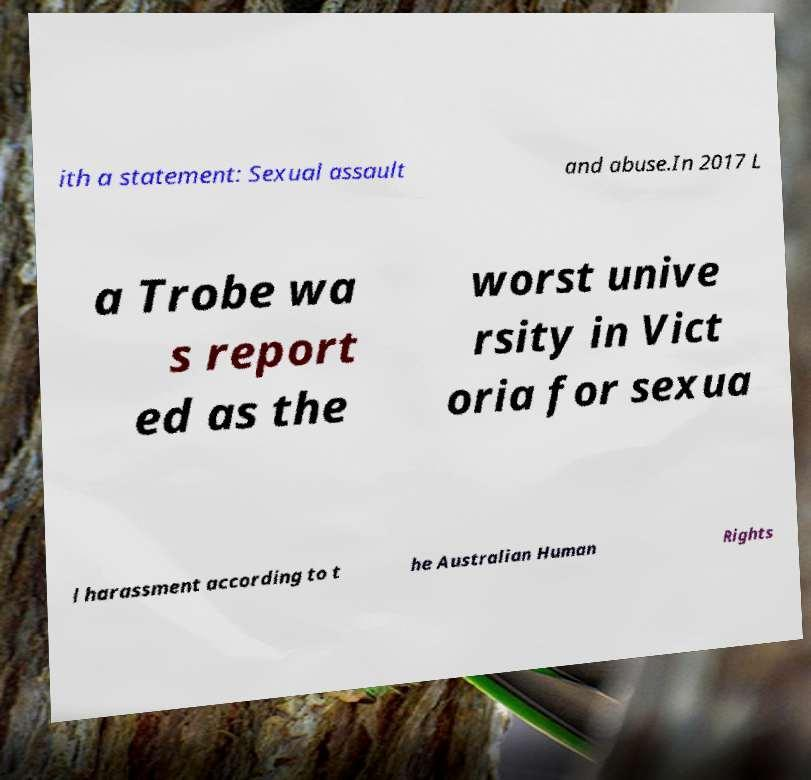Can you accurately transcribe the text from the provided image for me? ith a statement: Sexual assault and abuse.In 2017 L a Trobe wa s report ed as the worst unive rsity in Vict oria for sexua l harassment according to t he Australian Human Rights 